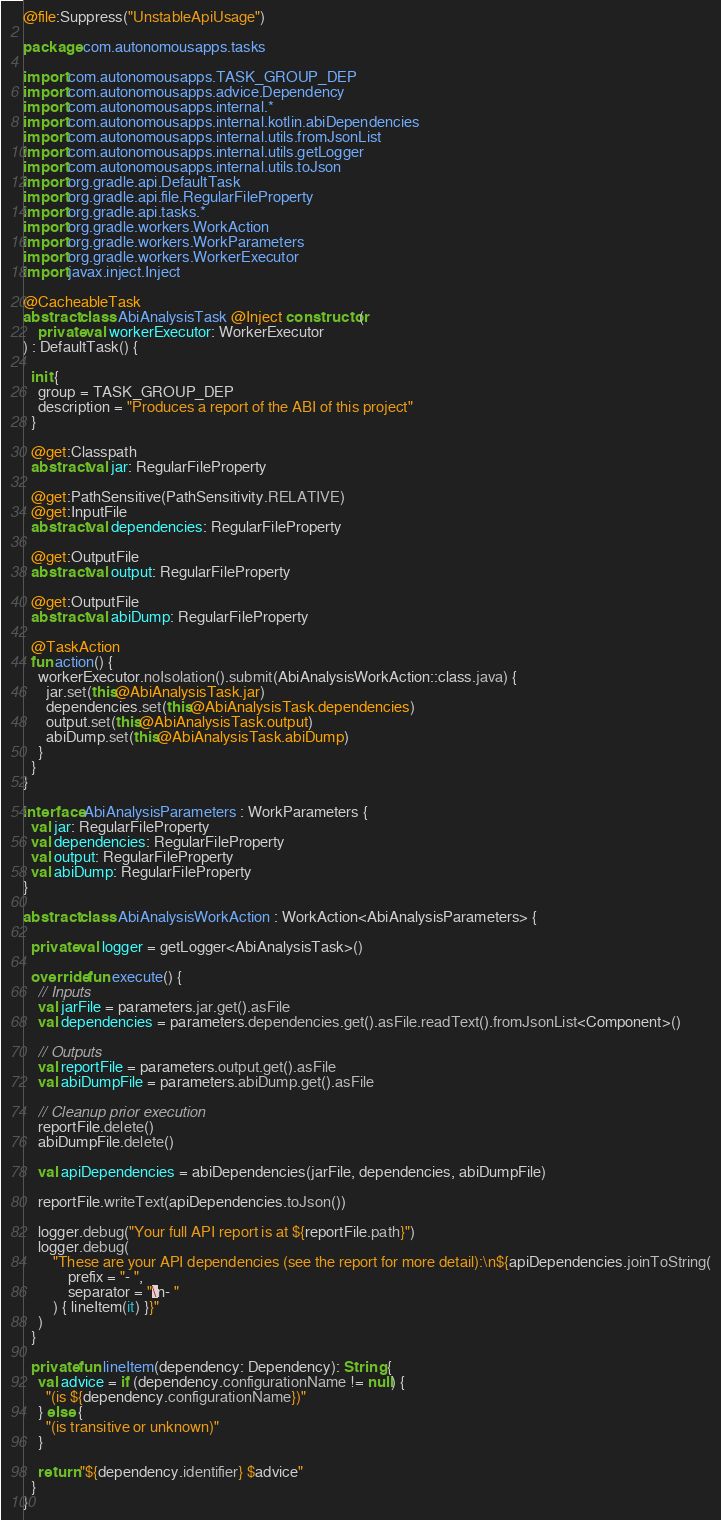<code> <loc_0><loc_0><loc_500><loc_500><_Kotlin_>@file:Suppress("UnstableApiUsage")

package com.autonomousapps.tasks

import com.autonomousapps.TASK_GROUP_DEP
import com.autonomousapps.advice.Dependency
import com.autonomousapps.internal.*
import com.autonomousapps.internal.kotlin.abiDependencies
import com.autonomousapps.internal.utils.fromJsonList
import com.autonomousapps.internal.utils.getLogger
import com.autonomousapps.internal.utils.toJson
import org.gradle.api.DefaultTask
import org.gradle.api.file.RegularFileProperty
import org.gradle.api.tasks.*
import org.gradle.workers.WorkAction
import org.gradle.workers.WorkParameters
import org.gradle.workers.WorkerExecutor
import javax.inject.Inject

@CacheableTask
abstract class AbiAnalysisTask @Inject constructor(
    private val workerExecutor: WorkerExecutor
) : DefaultTask() {

  init {
    group = TASK_GROUP_DEP
    description = "Produces a report of the ABI of this project"
  }

  @get:Classpath
  abstract val jar: RegularFileProperty

  @get:PathSensitive(PathSensitivity.RELATIVE)
  @get:InputFile
  abstract val dependencies: RegularFileProperty

  @get:OutputFile
  abstract val output: RegularFileProperty

  @get:OutputFile
  abstract val abiDump: RegularFileProperty

  @TaskAction
  fun action() {
    workerExecutor.noIsolation().submit(AbiAnalysisWorkAction::class.java) {
      jar.set(this@AbiAnalysisTask.jar)
      dependencies.set(this@AbiAnalysisTask.dependencies)
      output.set(this@AbiAnalysisTask.output)
      abiDump.set(this@AbiAnalysisTask.abiDump)
    }
  }
}

interface AbiAnalysisParameters : WorkParameters {
  val jar: RegularFileProperty
  val dependencies: RegularFileProperty
  val output: RegularFileProperty
  val abiDump: RegularFileProperty
}

abstract class AbiAnalysisWorkAction : WorkAction<AbiAnalysisParameters> {

  private val logger = getLogger<AbiAnalysisTask>()

  override fun execute() {
    // Inputs
    val jarFile = parameters.jar.get().asFile
    val dependencies = parameters.dependencies.get().asFile.readText().fromJsonList<Component>()

    // Outputs
    val reportFile = parameters.output.get().asFile
    val abiDumpFile = parameters.abiDump.get().asFile

    // Cleanup prior execution
    reportFile.delete()
    abiDumpFile.delete()

    val apiDependencies = abiDependencies(jarFile, dependencies, abiDumpFile)

    reportFile.writeText(apiDependencies.toJson())

    logger.debug("Your full API report is at ${reportFile.path}")
    logger.debug(
        "These are your API dependencies (see the report for more detail):\n${apiDependencies.joinToString(
            prefix = "- ",
            separator = "\n- "
        ) { lineItem(it) }}"
    )
  }

  private fun lineItem(dependency: Dependency): String {
    val advice = if (dependency.configurationName != null) {
      "(is ${dependency.configurationName})"
    } else {
      "(is transitive or unknown)"
    }

    return "${dependency.identifier} $advice"
  }
}


</code> 